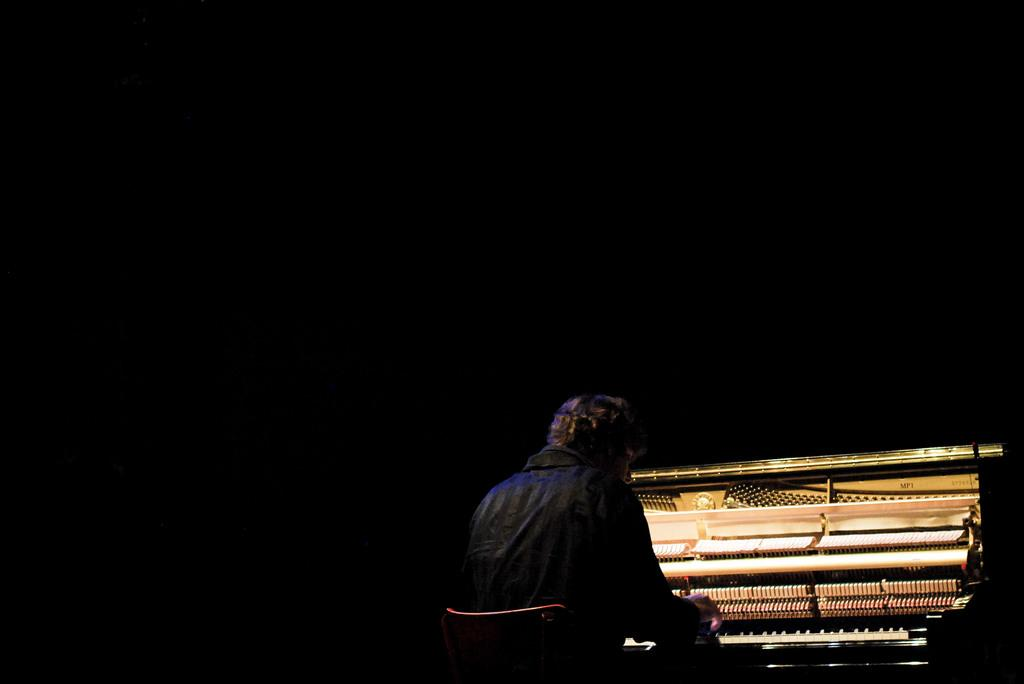Who is the main subject in the image? There is a man in the image. What is the man doing in the image? The man is playing a piano. What is the man's position in the image? The man is sitting in a chair. How many bikes are parked next to the man in the image? There are no bikes present in the image. What type of credit does the man have for playing the piano in the image? The image does not provide information about the man's credit for playing the piano. 